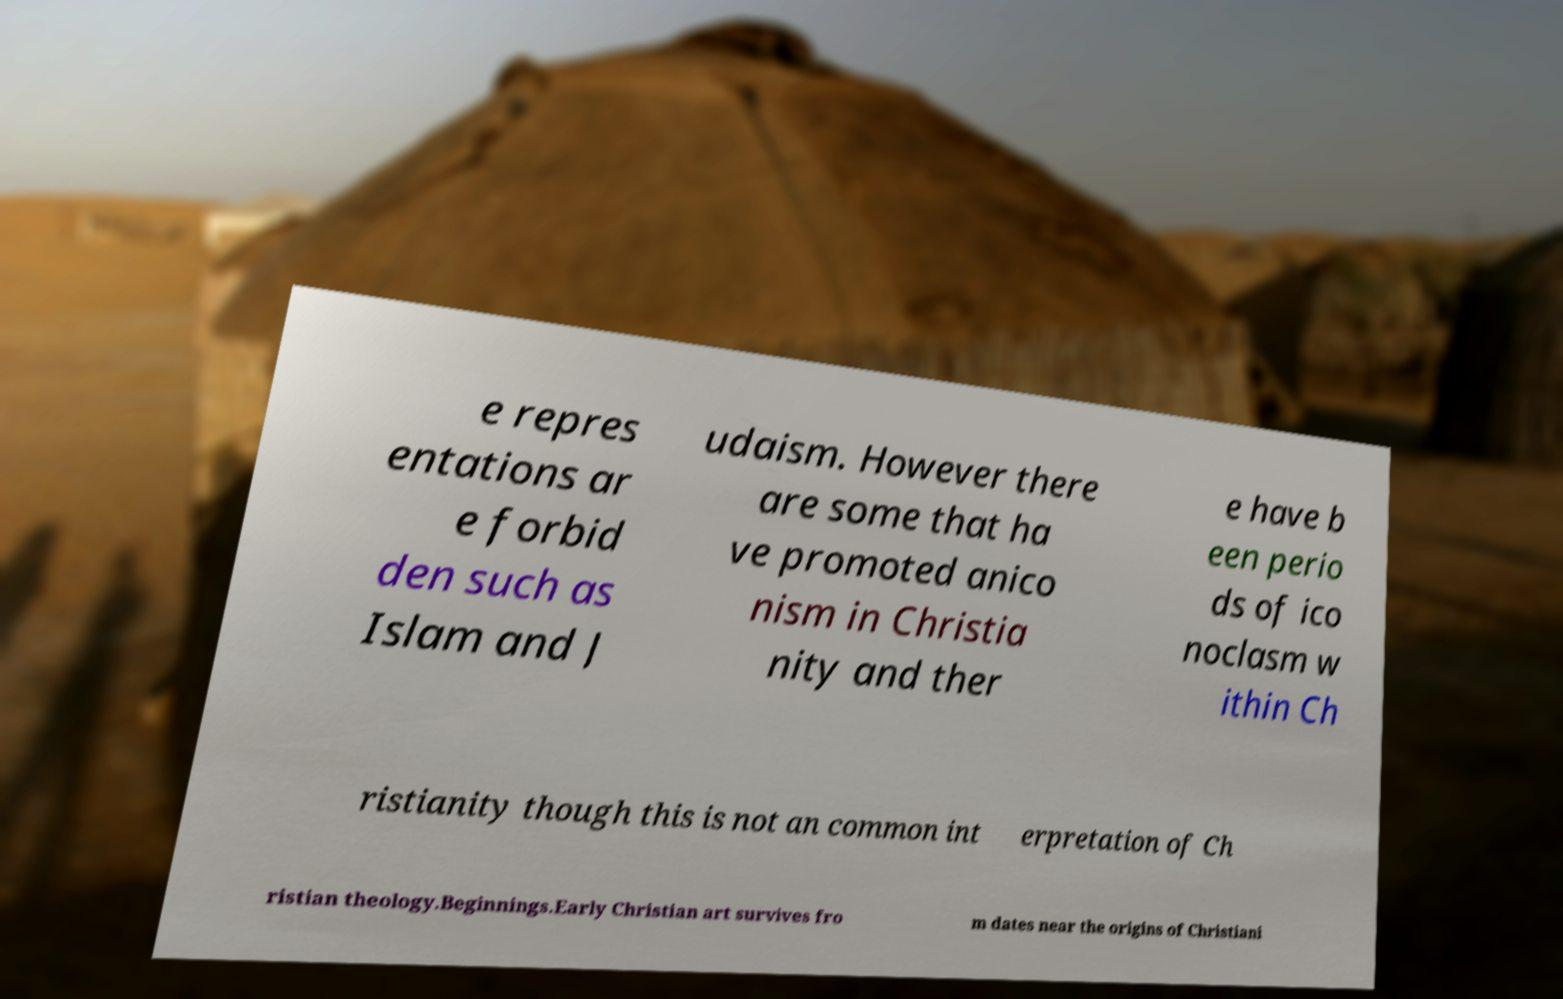What messages or text are displayed in this image? I need them in a readable, typed format. e repres entations ar e forbid den such as Islam and J udaism. However there are some that ha ve promoted anico nism in Christia nity and ther e have b een perio ds of ico noclasm w ithin Ch ristianity though this is not an common int erpretation of Ch ristian theology.Beginnings.Early Christian art survives fro m dates near the origins of Christiani 